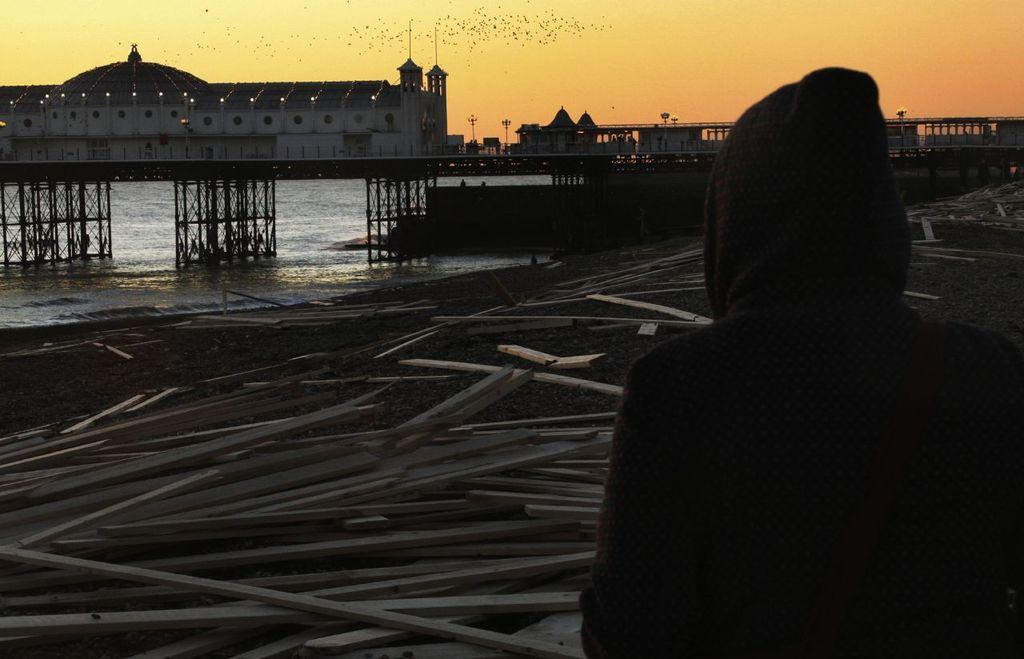What is the main subject in the image? There is a man standing in the image. What structure can be seen in the background? There is a bridge in the image. What natural element is visible in the image? There is water visible in the image. What type of man-made structure is present in the image? There is a building in the image. What source of illumination is present in the image? There is a light in the image. What part of the natural environment is visible in the image? The sky is visible in the image. What type of ship can be seen sailing in the night sky in the image? There is no ship visible in the image, and the sky is not described as nighttime. 